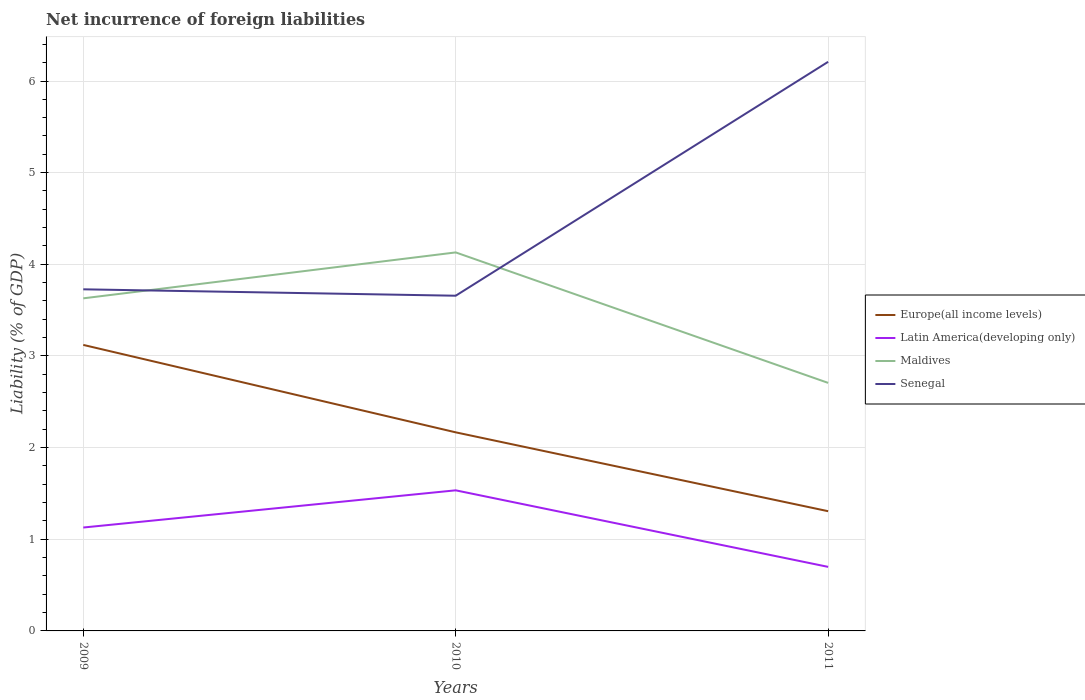How many different coloured lines are there?
Offer a terse response. 4. Does the line corresponding to Maldives intersect with the line corresponding to Senegal?
Provide a short and direct response. Yes. Is the number of lines equal to the number of legend labels?
Your response must be concise. Yes. Across all years, what is the maximum net incurrence of foreign liabilities in Maldives?
Provide a succinct answer. 2.71. What is the total net incurrence of foreign liabilities in Senegal in the graph?
Your response must be concise. -2.48. What is the difference between the highest and the second highest net incurrence of foreign liabilities in Maldives?
Provide a succinct answer. 1.42. What is the difference between the highest and the lowest net incurrence of foreign liabilities in Europe(all income levels)?
Provide a succinct answer. 1. Is the net incurrence of foreign liabilities in Senegal strictly greater than the net incurrence of foreign liabilities in Latin America(developing only) over the years?
Offer a terse response. No. Does the graph contain any zero values?
Provide a short and direct response. No. Does the graph contain grids?
Offer a terse response. Yes. Where does the legend appear in the graph?
Your response must be concise. Center right. How many legend labels are there?
Give a very brief answer. 4. How are the legend labels stacked?
Make the answer very short. Vertical. What is the title of the graph?
Offer a terse response. Net incurrence of foreign liabilities. Does "Seychelles" appear as one of the legend labels in the graph?
Ensure brevity in your answer.  No. What is the label or title of the X-axis?
Offer a very short reply. Years. What is the label or title of the Y-axis?
Your answer should be compact. Liability (% of GDP). What is the Liability (% of GDP) of Europe(all income levels) in 2009?
Provide a succinct answer. 3.12. What is the Liability (% of GDP) of Latin America(developing only) in 2009?
Give a very brief answer. 1.13. What is the Liability (% of GDP) in Maldives in 2009?
Your answer should be very brief. 3.63. What is the Liability (% of GDP) in Senegal in 2009?
Ensure brevity in your answer.  3.73. What is the Liability (% of GDP) in Europe(all income levels) in 2010?
Provide a succinct answer. 2.17. What is the Liability (% of GDP) of Latin America(developing only) in 2010?
Provide a succinct answer. 1.53. What is the Liability (% of GDP) in Maldives in 2010?
Keep it short and to the point. 4.13. What is the Liability (% of GDP) of Senegal in 2010?
Ensure brevity in your answer.  3.66. What is the Liability (% of GDP) of Europe(all income levels) in 2011?
Your answer should be very brief. 1.31. What is the Liability (% of GDP) in Latin America(developing only) in 2011?
Your answer should be very brief. 0.7. What is the Liability (% of GDP) in Maldives in 2011?
Provide a short and direct response. 2.71. What is the Liability (% of GDP) in Senegal in 2011?
Provide a short and direct response. 6.21. Across all years, what is the maximum Liability (% of GDP) of Europe(all income levels)?
Your answer should be very brief. 3.12. Across all years, what is the maximum Liability (% of GDP) of Latin America(developing only)?
Offer a terse response. 1.53. Across all years, what is the maximum Liability (% of GDP) in Maldives?
Offer a very short reply. 4.13. Across all years, what is the maximum Liability (% of GDP) of Senegal?
Make the answer very short. 6.21. Across all years, what is the minimum Liability (% of GDP) of Europe(all income levels)?
Offer a very short reply. 1.31. Across all years, what is the minimum Liability (% of GDP) of Latin America(developing only)?
Ensure brevity in your answer.  0.7. Across all years, what is the minimum Liability (% of GDP) of Maldives?
Offer a very short reply. 2.71. Across all years, what is the minimum Liability (% of GDP) of Senegal?
Make the answer very short. 3.66. What is the total Liability (% of GDP) of Europe(all income levels) in the graph?
Offer a terse response. 6.59. What is the total Liability (% of GDP) in Latin America(developing only) in the graph?
Offer a terse response. 3.36. What is the total Liability (% of GDP) in Maldives in the graph?
Your answer should be compact. 10.46. What is the total Liability (% of GDP) of Senegal in the graph?
Provide a short and direct response. 13.59. What is the difference between the Liability (% of GDP) in Europe(all income levels) in 2009 and that in 2010?
Give a very brief answer. 0.95. What is the difference between the Liability (% of GDP) of Latin America(developing only) in 2009 and that in 2010?
Offer a terse response. -0.41. What is the difference between the Liability (% of GDP) of Maldives in 2009 and that in 2010?
Provide a short and direct response. -0.5. What is the difference between the Liability (% of GDP) of Senegal in 2009 and that in 2010?
Your response must be concise. 0.07. What is the difference between the Liability (% of GDP) in Europe(all income levels) in 2009 and that in 2011?
Provide a short and direct response. 1.81. What is the difference between the Liability (% of GDP) of Latin America(developing only) in 2009 and that in 2011?
Make the answer very short. 0.43. What is the difference between the Liability (% of GDP) of Maldives in 2009 and that in 2011?
Provide a short and direct response. 0.92. What is the difference between the Liability (% of GDP) in Senegal in 2009 and that in 2011?
Give a very brief answer. -2.48. What is the difference between the Liability (% of GDP) in Europe(all income levels) in 2010 and that in 2011?
Your response must be concise. 0.86. What is the difference between the Liability (% of GDP) in Latin America(developing only) in 2010 and that in 2011?
Give a very brief answer. 0.84. What is the difference between the Liability (% of GDP) of Maldives in 2010 and that in 2011?
Provide a succinct answer. 1.42. What is the difference between the Liability (% of GDP) in Senegal in 2010 and that in 2011?
Provide a short and direct response. -2.55. What is the difference between the Liability (% of GDP) of Europe(all income levels) in 2009 and the Liability (% of GDP) of Latin America(developing only) in 2010?
Offer a very short reply. 1.59. What is the difference between the Liability (% of GDP) in Europe(all income levels) in 2009 and the Liability (% of GDP) in Maldives in 2010?
Ensure brevity in your answer.  -1.01. What is the difference between the Liability (% of GDP) in Europe(all income levels) in 2009 and the Liability (% of GDP) in Senegal in 2010?
Keep it short and to the point. -0.54. What is the difference between the Liability (% of GDP) of Latin America(developing only) in 2009 and the Liability (% of GDP) of Maldives in 2010?
Your response must be concise. -3. What is the difference between the Liability (% of GDP) in Latin America(developing only) in 2009 and the Liability (% of GDP) in Senegal in 2010?
Give a very brief answer. -2.53. What is the difference between the Liability (% of GDP) of Maldives in 2009 and the Liability (% of GDP) of Senegal in 2010?
Provide a succinct answer. -0.03. What is the difference between the Liability (% of GDP) of Europe(all income levels) in 2009 and the Liability (% of GDP) of Latin America(developing only) in 2011?
Make the answer very short. 2.42. What is the difference between the Liability (% of GDP) in Europe(all income levels) in 2009 and the Liability (% of GDP) in Maldives in 2011?
Offer a terse response. 0.41. What is the difference between the Liability (% of GDP) of Europe(all income levels) in 2009 and the Liability (% of GDP) of Senegal in 2011?
Provide a succinct answer. -3.09. What is the difference between the Liability (% of GDP) of Latin America(developing only) in 2009 and the Liability (% of GDP) of Maldives in 2011?
Provide a succinct answer. -1.58. What is the difference between the Liability (% of GDP) of Latin America(developing only) in 2009 and the Liability (% of GDP) of Senegal in 2011?
Your answer should be very brief. -5.08. What is the difference between the Liability (% of GDP) of Maldives in 2009 and the Liability (% of GDP) of Senegal in 2011?
Offer a very short reply. -2.58. What is the difference between the Liability (% of GDP) in Europe(all income levels) in 2010 and the Liability (% of GDP) in Latin America(developing only) in 2011?
Your response must be concise. 1.47. What is the difference between the Liability (% of GDP) in Europe(all income levels) in 2010 and the Liability (% of GDP) in Maldives in 2011?
Offer a terse response. -0.54. What is the difference between the Liability (% of GDP) in Europe(all income levels) in 2010 and the Liability (% of GDP) in Senegal in 2011?
Give a very brief answer. -4.04. What is the difference between the Liability (% of GDP) in Latin America(developing only) in 2010 and the Liability (% of GDP) in Maldives in 2011?
Your answer should be very brief. -1.17. What is the difference between the Liability (% of GDP) in Latin America(developing only) in 2010 and the Liability (% of GDP) in Senegal in 2011?
Your answer should be compact. -4.68. What is the difference between the Liability (% of GDP) of Maldives in 2010 and the Liability (% of GDP) of Senegal in 2011?
Your response must be concise. -2.08. What is the average Liability (% of GDP) of Europe(all income levels) per year?
Offer a terse response. 2.2. What is the average Liability (% of GDP) in Latin America(developing only) per year?
Provide a succinct answer. 1.12. What is the average Liability (% of GDP) in Maldives per year?
Provide a succinct answer. 3.49. What is the average Liability (% of GDP) of Senegal per year?
Your answer should be very brief. 4.53. In the year 2009, what is the difference between the Liability (% of GDP) of Europe(all income levels) and Liability (% of GDP) of Latin America(developing only)?
Offer a terse response. 1.99. In the year 2009, what is the difference between the Liability (% of GDP) of Europe(all income levels) and Liability (% of GDP) of Maldives?
Provide a succinct answer. -0.51. In the year 2009, what is the difference between the Liability (% of GDP) in Europe(all income levels) and Liability (% of GDP) in Senegal?
Your answer should be very brief. -0.61. In the year 2009, what is the difference between the Liability (% of GDP) in Latin America(developing only) and Liability (% of GDP) in Maldives?
Ensure brevity in your answer.  -2.5. In the year 2009, what is the difference between the Liability (% of GDP) of Latin America(developing only) and Liability (% of GDP) of Senegal?
Give a very brief answer. -2.6. In the year 2009, what is the difference between the Liability (% of GDP) in Maldives and Liability (% of GDP) in Senegal?
Your response must be concise. -0.1. In the year 2010, what is the difference between the Liability (% of GDP) of Europe(all income levels) and Liability (% of GDP) of Latin America(developing only)?
Keep it short and to the point. 0.63. In the year 2010, what is the difference between the Liability (% of GDP) of Europe(all income levels) and Liability (% of GDP) of Maldives?
Ensure brevity in your answer.  -1.96. In the year 2010, what is the difference between the Liability (% of GDP) in Europe(all income levels) and Liability (% of GDP) in Senegal?
Your answer should be compact. -1.49. In the year 2010, what is the difference between the Liability (% of GDP) in Latin America(developing only) and Liability (% of GDP) in Maldives?
Give a very brief answer. -2.6. In the year 2010, what is the difference between the Liability (% of GDP) of Latin America(developing only) and Liability (% of GDP) of Senegal?
Offer a terse response. -2.12. In the year 2010, what is the difference between the Liability (% of GDP) of Maldives and Liability (% of GDP) of Senegal?
Ensure brevity in your answer.  0.47. In the year 2011, what is the difference between the Liability (% of GDP) in Europe(all income levels) and Liability (% of GDP) in Latin America(developing only)?
Offer a very short reply. 0.61. In the year 2011, what is the difference between the Liability (% of GDP) in Europe(all income levels) and Liability (% of GDP) in Maldives?
Your response must be concise. -1.4. In the year 2011, what is the difference between the Liability (% of GDP) in Europe(all income levels) and Liability (% of GDP) in Senegal?
Ensure brevity in your answer.  -4.9. In the year 2011, what is the difference between the Liability (% of GDP) of Latin America(developing only) and Liability (% of GDP) of Maldives?
Your response must be concise. -2.01. In the year 2011, what is the difference between the Liability (% of GDP) in Latin America(developing only) and Liability (% of GDP) in Senegal?
Give a very brief answer. -5.51. In the year 2011, what is the difference between the Liability (% of GDP) of Maldives and Liability (% of GDP) of Senegal?
Make the answer very short. -3.5. What is the ratio of the Liability (% of GDP) in Europe(all income levels) in 2009 to that in 2010?
Provide a short and direct response. 1.44. What is the ratio of the Liability (% of GDP) in Latin America(developing only) in 2009 to that in 2010?
Make the answer very short. 0.74. What is the ratio of the Liability (% of GDP) in Maldives in 2009 to that in 2010?
Your answer should be compact. 0.88. What is the ratio of the Liability (% of GDP) of Senegal in 2009 to that in 2010?
Give a very brief answer. 1.02. What is the ratio of the Liability (% of GDP) in Europe(all income levels) in 2009 to that in 2011?
Keep it short and to the point. 2.39. What is the ratio of the Liability (% of GDP) in Latin America(developing only) in 2009 to that in 2011?
Keep it short and to the point. 1.61. What is the ratio of the Liability (% of GDP) of Maldives in 2009 to that in 2011?
Offer a terse response. 1.34. What is the ratio of the Liability (% of GDP) in Senegal in 2009 to that in 2011?
Ensure brevity in your answer.  0.6. What is the ratio of the Liability (% of GDP) in Europe(all income levels) in 2010 to that in 2011?
Give a very brief answer. 1.66. What is the ratio of the Liability (% of GDP) in Latin America(developing only) in 2010 to that in 2011?
Your answer should be compact. 2.2. What is the ratio of the Liability (% of GDP) in Maldives in 2010 to that in 2011?
Your answer should be compact. 1.53. What is the ratio of the Liability (% of GDP) of Senegal in 2010 to that in 2011?
Offer a very short reply. 0.59. What is the difference between the highest and the second highest Liability (% of GDP) of Europe(all income levels)?
Provide a short and direct response. 0.95. What is the difference between the highest and the second highest Liability (% of GDP) of Latin America(developing only)?
Provide a succinct answer. 0.41. What is the difference between the highest and the second highest Liability (% of GDP) in Maldives?
Make the answer very short. 0.5. What is the difference between the highest and the second highest Liability (% of GDP) in Senegal?
Provide a succinct answer. 2.48. What is the difference between the highest and the lowest Liability (% of GDP) in Europe(all income levels)?
Make the answer very short. 1.81. What is the difference between the highest and the lowest Liability (% of GDP) of Latin America(developing only)?
Offer a very short reply. 0.84. What is the difference between the highest and the lowest Liability (% of GDP) of Maldives?
Provide a succinct answer. 1.42. What is the difference between the highest and the lowest Liability (% of GDP) in Senegal?
Offer a terse response. 2.55. 